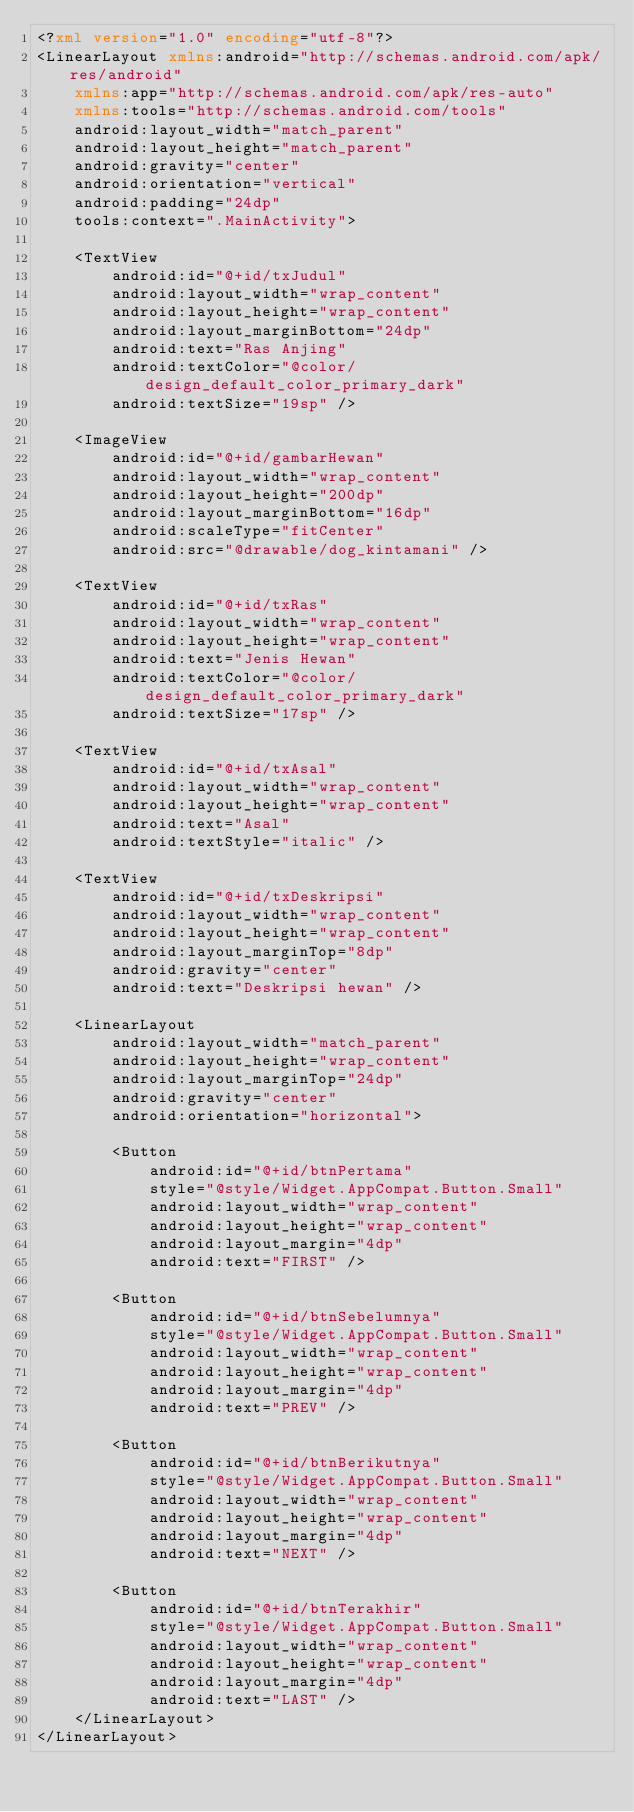Convert code to text. <code><loc_0><loc_0><loc_500><loc_500><_XML_><?xml version="1.0" encoding="utf-8"?>
<LinearLayout xmlns:android="http://schemas.android.com/apk/res/android"
    xmlns:app="http://schemas.android.com/apk/res-auto"
    xmlns:tools="http://schemas.android.com/tools"
    android:layout_width="match_parent"
    android:layout_height="match_parent"
    android:gravity="center"
    android:orientation="vertical"
    android:padding="24dp"
    tools:context=".MainActivity">

    <TextView
        android:id="@+id/txJudul"
        android:layout_width="wrap_content"
        android:layout_height="wrap_content"
        android:layout_marginBottom="24dp"
        android:text="Ras Anjing"
        android:textColor="@color/design_default_color_primary_dark"
        android:textSize="19sp" />

    <ImageView
        android:id="@+id/gambarHewan"
        android:layout_width="wrap_content"
        android:layout_height="200dp"
        android:layout_marginBottom="16dp"
        android:scaleType="fitCenter"
        android:src="@drawable/dog_kintamani" />

    <TextView
        android:id="@+id/txRas"
        android:layout_width="wrap_content"
        android:layout_height="wrap_content"
        android:text="Jenis Hewan"
        android:textColor="@color/design_default_color_primary_dark"
        android:textSize="17sp" />

    <TextView
        android:id="@+id/txAsal"
        android:layout_width="wrap_content"
        android:layout_height="wrap_content"
        android:text="Asal"
        android:textStyle="italic" />

    <TextView
        android:id="@+id/txDeskripsi"
        android:layout_width="wrap_content"
        android:layout_height="wrap_content"
        android:layout_marginTop="8dp"
        android:gravity="center"
        android:text="Deskripsi hewan" />

    <LinearLayout
        android:layout_width="match_parent"
        android:layout_height="wrap_content"
        android:layout_marginTop="24dp"
        android:gravity="center"
        android:orientation="horizontal">

        <Button
            android:id="@+id/btnPertama"
            style="@style/Widget.AppCompat.Button.Small"
            android:layout_width="wrap_content"
            android:layout_height="wrap_content"
            android:layout_margin="4dp"
            android:text="FIRST" />

        <Button
            android:id="@+id/btnSebelumnya"
            style="@style/Widget.AppCompat.Button.Small"
            android:layout_width="wrap_content"
            android:layout_height="wrap_content"
            android:layout_margin="4dp"
            android:text="PREV" />

        <Button
            android:id="@+id/btnBerikutnya"
            style="@style/Widget.AppCompat.Button.Small"
            android:layout_width="wrap_content"
            android:layout_height="wrap_content"
            android:layout_margin="4dp"
            android:text="NEXT" />

        <Button
            android:id="@+id/btnTerakhir"
            style="@style/Widget.AppCompat.Button.Small"
            android:layout_width="wrap_content"
            android:layout_height="wrap_content"
            android:layout_margin="4dp"
            android:text="LAST" />
    </LinearLayout>
</LinearLayout></code> 